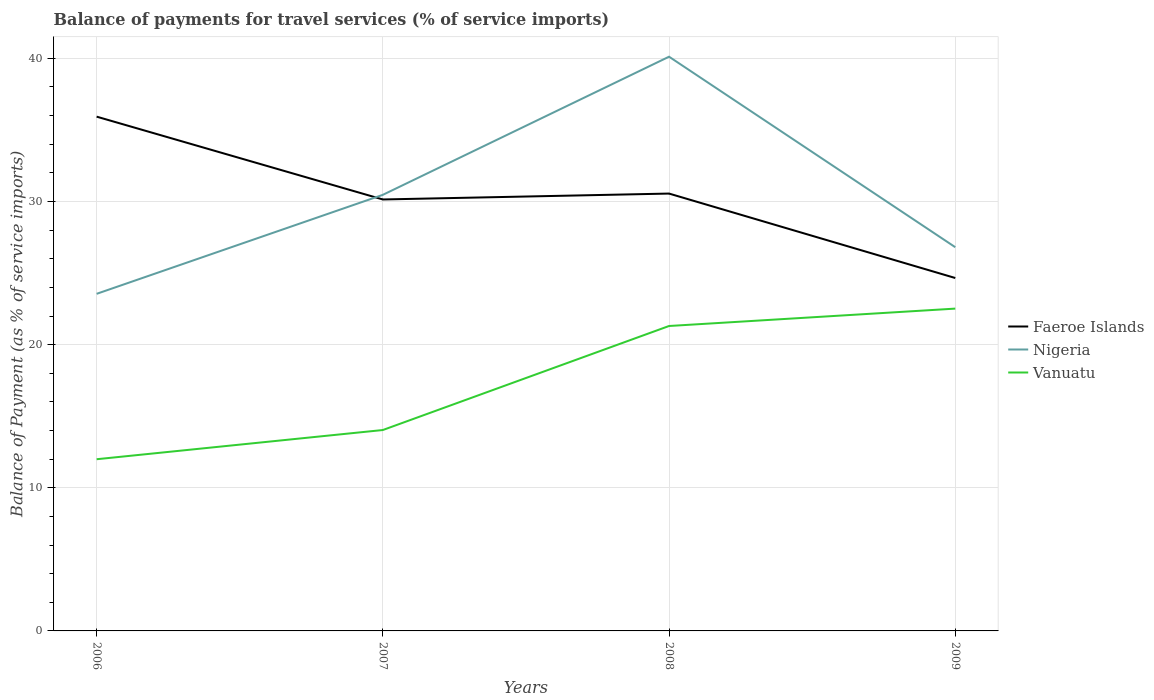Across all years, what is the maximum balance of payments for travel services in Faeroe Islands?
Your answer should be very brief. 24.65. What is the total balance of payments for travel services in Faeroe Islands in the graph?
Keep it short and to the point. -0.41. What is the difference between the highest and the second highest balance of payments for travel services in Vanuatu?
Ensure brevity in your answer.  10.52. Is the balance of payments for travel services in Vanuatu strictly greater than the balance of payments for travel services in Nigeria over the years?
Offer a terse response. Yes. How many lines are there?
Keep it short and to the point. 3. What is the difference between two consecutive major ticks on the Y-axis?
Your response must be concise. 10. Are the values on the major ticks of Y-axis written in scientific E-notation?
Provide a short and direct response. No. Does the graph contain grids?
Provide a succinct answer. Yes. How many legend labels are there?
Offer a terse response. 3. How are the legend labels stacked?
Offer a very short reply. Vertical. What is the title of the graph?
Your response must be concise. Balance of payments for travel services (% of service imports). What is the label or title of the X-axis?
Your answer should be very brief. Years. What is the label or title of the Y-axis?
Keep it short and to the point. Balance of Payment (as % of service imports). What is the Balance of Payment (as % of service imports) of Faeroe Islands in 2006?
Offer a very short reply. 35.93. What is the Balance of Payment (as % of service imports) in Nigeria in 2006?
Ensure brevity in your answer.  23.55. What is the Balance of Payment (as % of service imports) of Vanuatu in 2006?
Provide a short and direct response. 11.99. What is the Balance of Payment (as % of service imports) in Faeroe Islands in 2007?
Your answer should be very brief. 30.14. What is the Balance of Payment (as % of service imports) in Nigeria in 2007?
Offer a very short reply. 30.47. What is the Balance of Payment (as % of service imports) in Vanuatu in 2007?
Ensure brevity in your answer.  14.03. What is the Balance of Payment (as % of service imports) of Faeroe Islands in 2008?
Provide a succinct answer. 30.55. What is the Balance of Payment (as % of service imports) in Nigeria in 2008?
Offer a very short reply. 40.12. What is the Balance of Payment (as % of service imports) of Vanuatu in 2008?
Offer a very short reply. 21.3. What is the Balance of Payment (as % of service imports) of Faeroe Islands in 2009?
Make the answer very short. 24.65. What is the Balance of Payment (as % of service imports) in Nigeria in 2009?
Keep it short and to the point. 26.81. What is the Balance of Payment (as % of service imports) of Vanuatu in 2009?
Ensure brevity in your answer.  22.52. Across all years, what is the maximum Balance of Payment (as % of service imports) of Faeroe Islands?
Give a very brief answer. 35.93. Across all years, what is the maximum Balance of Payment (as % of service imports) in Nigeria?
Offer a terse response. 40.12. Across all years, what is the maximum Balance of Payment (as % of service imports) in Vanuatu?
Your answer should be very brief. 22.52. Across all years, what is the minimum Balance of Payment (as % of service imports) of Faeroe Islands?
Ensure brevity in your answer.  24.65. Across all years, what is the minimum Balance of Payment (as % of service imports) of Nigeria?
Offer a very short reply. 23.55. Across all years, what is the minimum Balance of Payment (as % of service imports) in Vanuatu?
Provide a short and direct response. 11.99. What is the total Balance of Payment (as % of service imports) in Faeroe Islands in the graph?
Offer a very short reply. 121.28. What is the total Balance of Payment (as % of service imports) in Nigeria in the graph?
Keep it short and to the point. 120.94. What is the total Balance of Payment (as % of service imports) of Vanuatu in the graph?
Your answer should be very brief. 69.85. What is the difference between the Balance of Payment (as % of service imports) of Faeroe Islands in 2006 and that in 2007?
Offer a terse response. 5.79. What is the difference between the Balance of Payment (as % of service imports) of Nigeria in 2006 and that in 2007?
Make the answer very short. -6.92. What is the difference between the Balance of Payment (as % of service imports) of Vanuatu in 2006 and that in 2007?
Provide a succinct answer. -2.04. What is the difference between the Balance of Payment (as % of service imports) of Faeroe Islands in 2006 and that in 2008?
Your answer should be very brief. 5.37. What is the difference between the Balance of Payment (as % of service imports) in Nigeria in 2006 and that in 2008?
Your answer should be compact. -16.57. What is the difference between the Balance of Payment (as % of service imports) of Vanuatu in 2006 and that in 2008?
Keep it short and to the point. -9.31. What is the difference between the Balance of Payment (as % of service imports) in Faeroe Islands in 2006 and that in 2009?
Your response must be concise. 11.27. What is the difference between the Balance of Payment (as % of service imports) of Nigeria in 2006 and that in 2009?
Your answer should be very brief. -3.26. What is the difference between the Balance of Payment (as % of service imports) in Vanuatu in 2006 and that in 2009?
Your response must be concise. -10.52. What is the difference between the Balance of Payment (as % of service imports) in Faeroe Islands in 2007 and that in 2008?
Provide a short and direct response. -0.41. What is the difference between the Balance of Payment (as % of service imports) in Nigeria in 2007 and that in 2008?
Make the answer very short. -9.65. What is the difference between the Balance of Payment (as % of service imports) of Vanuatu in 2007 and that in 2008?
Make the answer very short. -7.27. What is the difference between the Balance of Payment (as % of service imports) in Faeroe Islands in 2007 and that in 2009?
Provide a short and direct response. 5.49. What is the difference between the Balance of Payment (as % of service imports) in Nigeria in 2007 and that in 2009?
Provide a succinct answer. 3.66. What is the difference between the Balance of Payment (as % of service imports) of Vanuatu in 2007 and that in 2009?
Offer a terse response. -8.48. What is the difference between the Balance of Payment (as % of service imports) of Faeroe Islands in 2008 and that in 2009?
Offer a very short reply. 5.9. What is the difference between the Balance of Payment (as % of service imports) in Nigeria in 2008 and that in 2009?
Keep it short and to the point. 13.31. What is the difference between the Balance of Payment (as % of service imports) of Vanuatu in 2008 and that in 2009?
Your response must be concise. -1.21. What is the difference between the Balance of Payment (as % of service imports) in Faeroe Islands in 2006 and the Balance of Payment (as % of service imports) in Nigeria in 2007?
Give a very brief answer. 5.46. What is the difference between the Balance of Payment (as % of service imports) of Faeroe Islands in 2006 and the Balance of Payment (as % of service imports) of Vanuatu in 2007?
Your answer should be very brief. 21.89. What is the difference between the Balance of Payment (as % of service imports) of Nigeria in 2006 and the Balance of Payment (as % of service imports) of Vanuatu in 2007?
Give a very brief answer. 9.52. What is the difference between the Balance of Payment (as % of service imports) in Faeroe Islands in 2006 and the Balance of Payment (as % of service imports) in Nigeria in 2008?
Provide a short and direct response. -4.19. What is the difference between the Balance of Payment (as % of service imports) in Faeroe Islands in 2006 and the Balance of Payment (as % of service imports) in Vanuatu in 2008?
Your response must be concise. 14.63. What is the difference between the Balance of Payment (as % of service imports) of Nigeria in 2006 and the Balance of Payment (as % of service imports) of Vanuatu in 2008?
Offer a very short reply. 2.25. What is the difference between the Balance of Payment (as % of service imports) in Faeroe Islands in 2006 and the Balance of Payment (as % of service imports) in Nigeria in 2009?
Your response must be concise. 9.12. What is the difference between the Balance of Payment (as % of service imports) in Faeroe Islands in 2006 and the Balance of Payment (as % of service imports) in Vanuatu in 2009?
Keep it short and to the point. 13.41. What is the difference between the Balance of Payment (as % of service imports) in Nigeria in 2006 and the Balance of Payment (as % of service imports) in Vanuatu in 2009?
Your response must be concise. 1.03. What is the difference between the Balance of Payment (as % of service imports) of Faeroe Islands in 2007 and the Balance of Payment (as % of service imports) of Nigeria in 2008?
Ensure brevity in your answer.  -9.97. What is the difference between the Balance of Payment (as % of service imports) of Faeroe Islands in 2007 and the Balance of Payment (as % of service imports) of Vanuatu in 2008?
Offer a terse response. 8.84. What is the difference between the Balance of Payment (as % of service imports) of Nigeria in 2007 and the Balance of Payment (as % of service imports) of Vanuatu in 2008?
Give a very brief answer. 9.16. What is the difference between the Balance of Payment (as % of service imports) of Faeroe Islands in 2007 and the Balance of Payment (as % of service imports) of Nigeria in 2009?
Provide a succinct answer. 3.33. What is the difference between the Balance of Payment (as % of service imports) in Faeroe Islands in 2007 and the Balance of Payment (as % of service imports) in Vanuatu in 2009?
Offer a terse response. 7.62. What is the difference between the Balance of Payment (as % of service imports) of Nigeria in 2007 and the Balance of Payment (as % of service imports) of Vanuatu in 2009?
Make the answer very short. 7.95. What is the difference between the Balance of Payment (as % of service imports) in Faeroe Islands in 2008 and the Balance of Payment (as % of service imports) in Nigeria in 2009?
Ensure brevity in your answer.  3.75. What is the difference between the Balance of Payment (as % of service imports) in Faeroe Islands in 2008 and the Balance of Payment (as % of service imports) in Vanuatu in 2009?
Ensure brevity in your answer.  8.04. What is the difference between the Balance of Payment (as % of service imports) of Nigeria in 2008 and the Balance of Payment (as % of service imports) of Vanuatu in 2009?
Your answer should be compact. 17.6. What is the average Balance of Payment (as % of service imports) of Faeroe Islands per year?
Offer a very short reply. 30.32. What is the average Balance of Payment (as % of service imports) of Nigeria per year?
Keep it short and to the point. 30.23. What is the average Balance of Payment (as % of service imports) in Vanuatu per year?
Keep it short and to the point. 17.46. In the year 2006, what is the difference between the Balance of Payment (as % of service imports) of Faeroe Islands and Balance of Payment (as % of service imports) of Nigeria?
Keep it short and to the point. 12.38. In the year 2006, what is the difference between the Balance of Payment (as % of service imports) in Faeroe Islands and Balance of Payment (as % of service imports) in Vanuatu?
Your answer should be compact. 23.93. In the year 2006, what is the difference between the Balance of Payment (as % of service imports) in Nigeria and Balance of Payment (as % of service imports) in Vanuatu?
Offer a very short reply. 11.56. In the year 2007, what is the difference between the Balance of Payment (as % of service imports) of Faeroe Islands and Balance of Payment (as % of service imports) of Nigeria?
Keep it short and to the point. -0.33. In the year 2007, what is the difference between the Balance of Payment (as % of service imports) of Faeroe Islands and Balance of Payment (as % of service imports) of Vanuatu?
Keep it short and to the point. 16.11. In the year 2007, what is the difference between the Balance of Payment (as % of service imports) in Nigeria and Balance of Payment (as % of service imports) in Vanuatu?
Give a very brief answer. 16.43. In the year 2008, what is the difference between the Balance of Payment (as % of service imports) of Faeroe Islands and Balance of Payment (as % of service imports) of Nigeria?
Make the answer very short. -9.56. In the year 2008, what is the difference between the Balance of Payment (as % of service imports) in Faeroe Islands and Balance of Payment (as % of service imports) in Vanuatu?
Ensure brevity in your answer.  9.25. In the year 2008, what is the difference between the Balance of Payment (as % of service imports) of Nigeria and Balance of Payment (as % of service imports) of Vanuatu?
Your answer should be compact. 18.81. In the year 2009, what is the difference between the Balance of Payment (as % of service imports) of Faeroe Islands and Balance of Payment (as % of service imports) of Nigeria?
Offer a terse response. -2.15. In the year 2009, what is the difference between the Balance of Payment (as % of service imports) of Faeroe Islands and Balance of Payment (as % of service imports) of Vanuatu?
Your answer should be compact. 2.14. In the year 2009, what is the difference between the Balance of Payment (as % of service imports) of Nigeria and Balance of Payment (as % of service imports) of Vanuatu?
Offer a very short reply. 4.29. What is the ratio of the Balance of Payment (as % of service imports) of Faeroe Islands in 2006 to that in 2007?
Your response must be concise. 1.19. What is the ratio of the Balance of Payment (as % of service imports) in Nigeria in 2006 to that in 2007?
Provide a succinct answer. 0.77. What is the ratio of the Balance of Payment (as % of service imports) in Vanuatu in 2006 to that in 2007?
Your response must be concise. 0.85. What is the ratio of the Balance of Payment (as % of service imports) in Faeroe Islands in 2006 to that in 2008?
Your answer should be compact. 1.18. What is the ratio of the Balance of Payment (as % of service imports) in Nigeria in 2006 to that in 2008?
Offer a very short reply. 0.59. What is the ratio of the Balance of Payment (as % of service imports) of Vanuatu in 2006 to that in 2008?
Keep it short and to the point. 0.56. What is the ratio of the Balance of Payment (as % of service imports) in Faeroe Islands in 2006 to that in 2009?
Your answer should be very brief. 1.46. What is the ratio of the Balance of Payment (as % of service imports) of Nigeria in 2006 to that in 2009?
Provide a short and direct response. 0.88. What is the ratio of the Balance of Payment (as % of service imports) of Vanuatu in 2006 to that in 2009?
Your answer should be compact. 0.53. What is the ratio of the Balance of Payment (as % of service imports) in Faeroe Islands in 2007 to that in 2008?
Your answer should be compact. 0.99. What is the ratio of the Balance of Payment (as % of service imports) of Nigeria in 2007 to that in 2008?
Make the answer very short. 0.76. What is the ratio of the Balance of Payment (as % of service imports) of Vanuatu in 2007 to that in 2008?
Offer a very short reply. 0.66. What is the ratio of the Balance of Payment (as % of service imports) in Faeroe Islands in 2007 to that in 2009?
Keep it short and to the point. 1.22. What is the ratio of the Balance of Payment (as % of service imports) of Nigeria in 2007 to that in 2009?
Make the answer very short. 1.14. What is the ratio of the Balance of Payment (as % of service imports) in Vanuatu in 2007 to that in 2009?
Give a very brief answer. 0.62. What is the ratio of the Balance of Payment (as % of service imports) in Faeroe Islands in 2008 to that in 2009?
Ensure brevity in your answer.  1.24. What is the ratio of the Balance of Payment (as % of service imports) in Nigeria in 2008 to that in 2009?
Keep it short and to the point. 1.5. What is the ratio of the Balance of Payment (as % of service imports) of Vanuatu in 2008 to that in 2009?
Give a very brief answer. 0.95. What is the difference between the highest and the second highest Balance of Payment (as % of service imports) in Faeroe Islands?
Give a very brief answer. 5.37. What is the difference between the highest and the second highest Balance of Payment (as % of service imports) of Nigeria?
Provide a short and direct response. 9.65. What is the difference between the highest and the second highest Balance of Payment (as % of service imports) of Vanuatu?
Give a very brief answer. 1.21. What is the difference between the highest and the lowest Balance of Payment (as % of service imports) in Faeroe Islands?
Make the answer very short. 11.27. What is the difference between the highest and the lowest Balance of Payment (as % of service imports) in Nigeria?
Make the answer very short. 16.57. What is the difference between the highest and the lowest Balance of Payment (as % of service imports) in Vanuatu?
Your answer should be very brief. 10.52. 